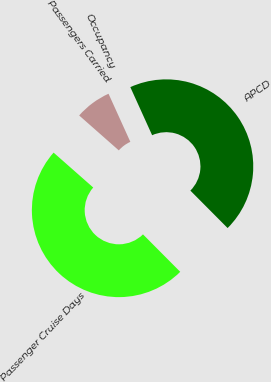<chart> <loc_0><loc_0><loc_500><loc_500><pie_chart><fcel>Passengers Carried<fcel>Passenger Cruise Days<fcel>APCD<fcel>Occupancy<nl><fcel>6.73%<fcel>48.95%<fcel>44.32%<fcel>0.0%<nl></chart> 